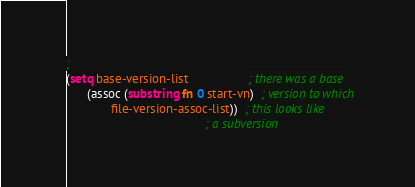Convert code to text. <code><loc_0><loc_0><loc_500><loc_500><_Clojure_>;
(setq base-version-list                 ; there was a base
      (assoc (substring fn 0 start-vn)  ; version to which
             file-version-assoc-list))  ; this looks like
                                        ; a subversion</code> 